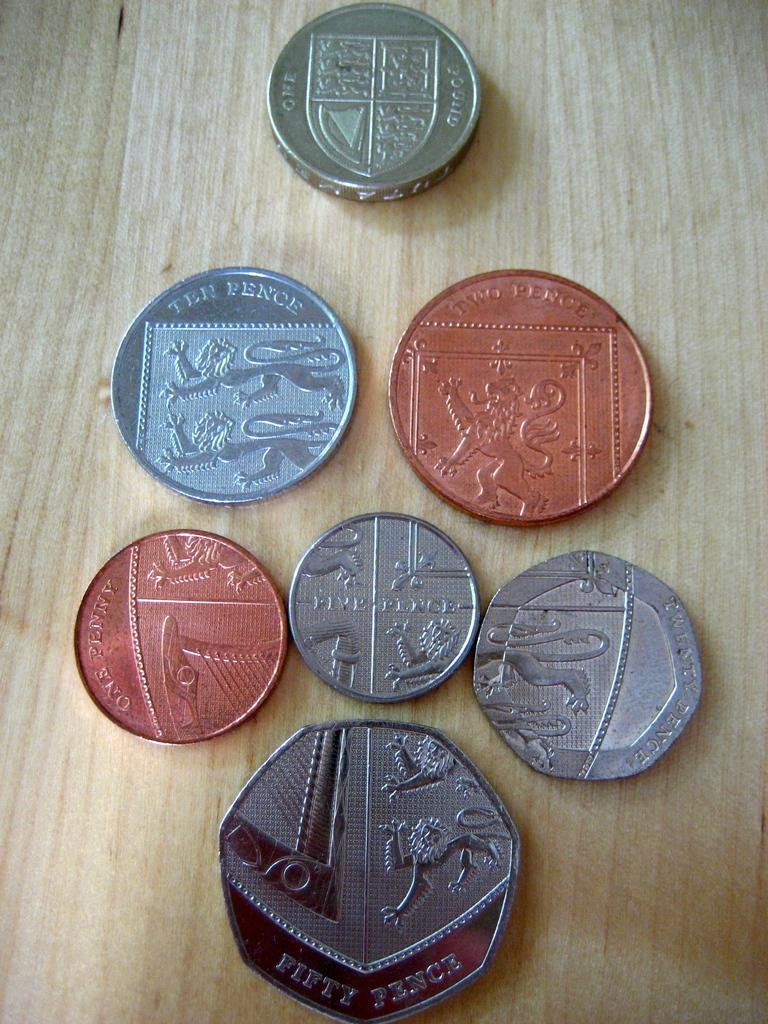<image>
Summarize the visual content of the image. The biggest coin at the bottom of the table says "Fifty Pence." 